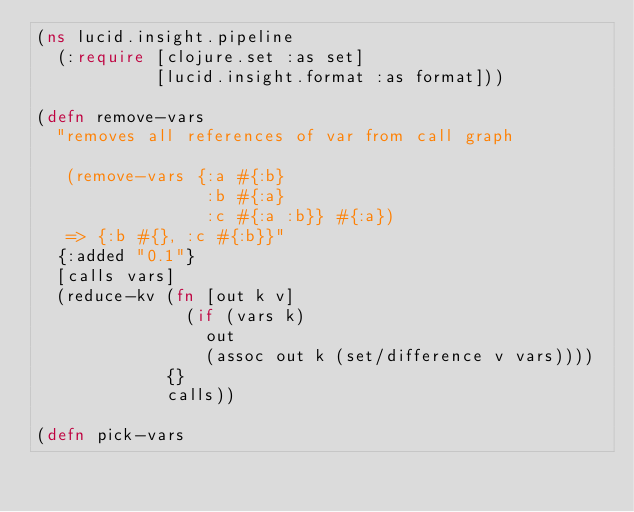<code> <loc_0><loc_0><loc_500><loc_500><_Clojure_>(ns lucid.insight.pipeline
  (:require [clojure.set :as set]
            [lucid.insight.format :as format]))

(defn remove-vars
  "removes all references of var from call graph
 
   (remove-vars {:a #{:b}
                 :b #{:a}
                 :c #{:a :b}} #{:a})
   => {:b #{}, :c #{:b}}"
  {:added "0.1"}
  [calls vars]
  (reduce-kv (fn [out k v]
               (if (vars k)
                 out
                 (assoc out k (set/difference v vars))))
             {}
             calls))

(defn pick-vars</code> 